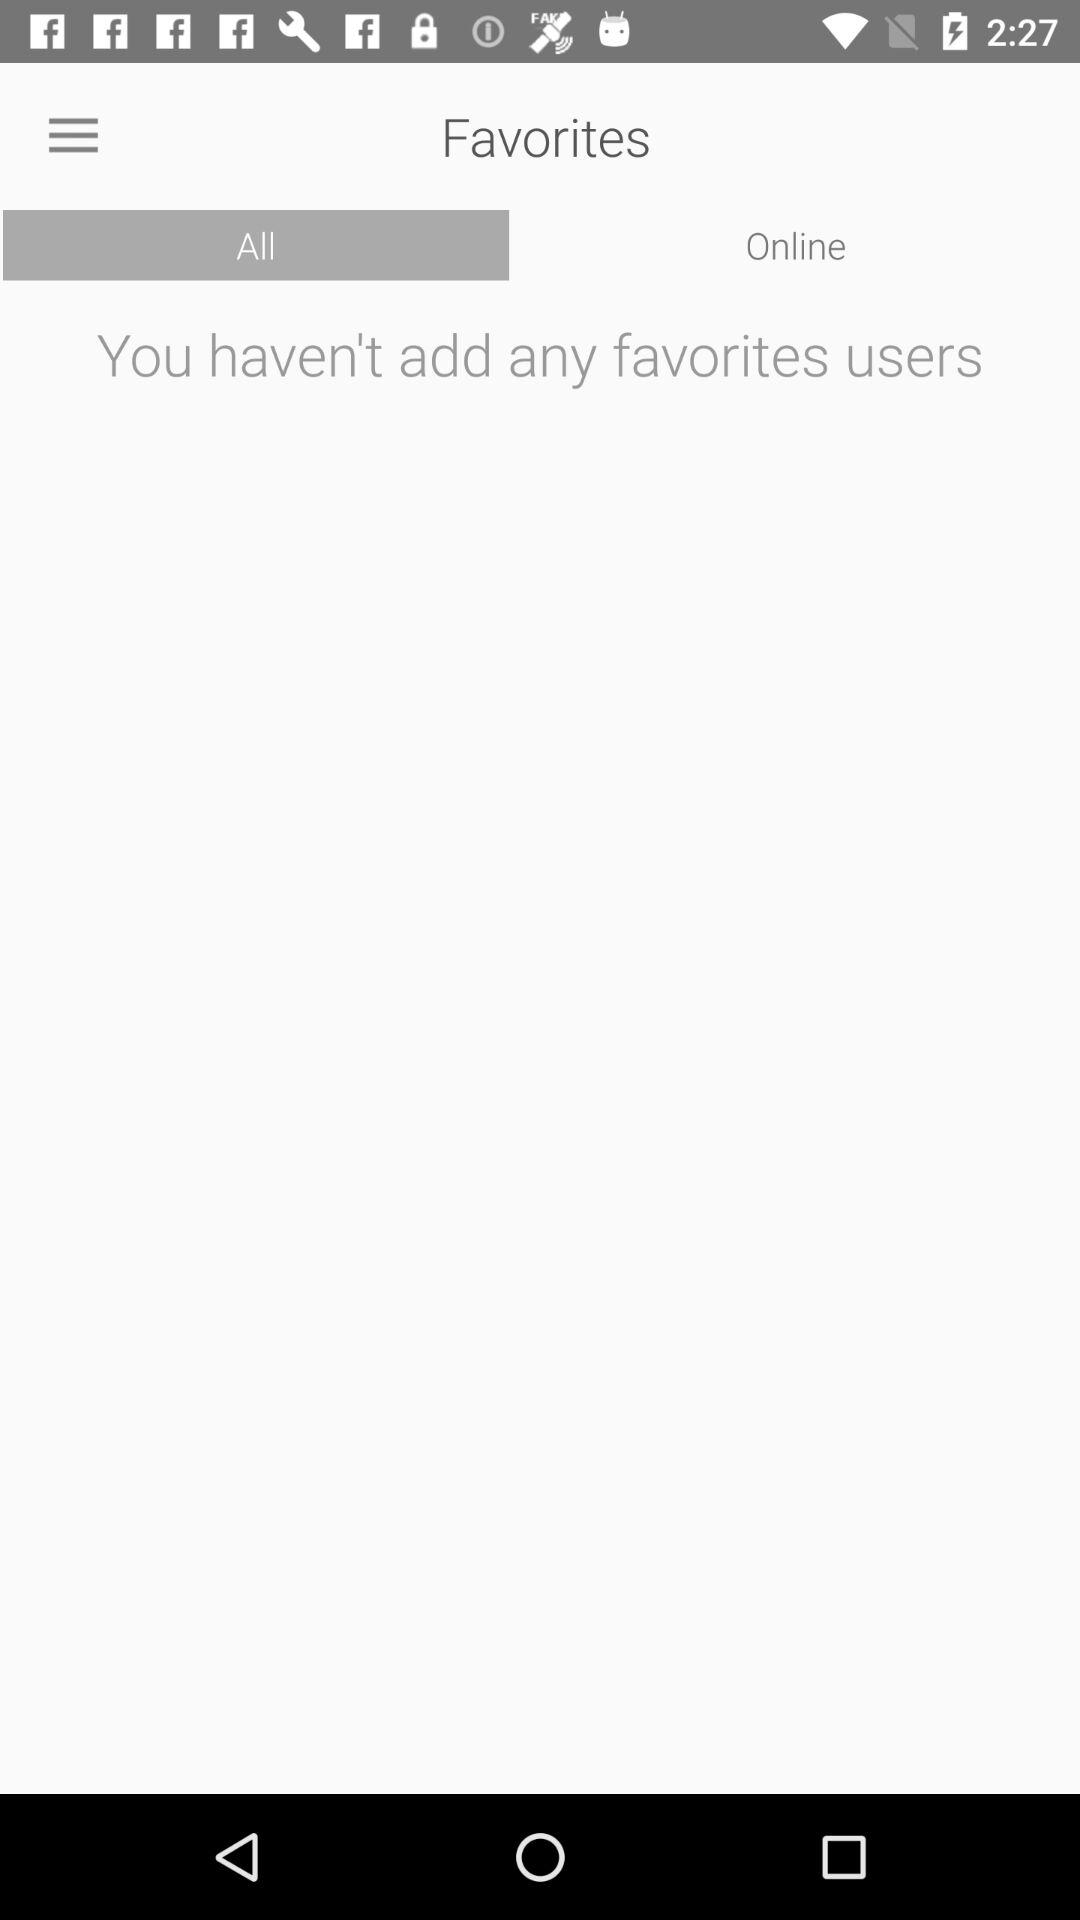Is there any favorite user added?
When the provided information is insufficient, respond with <no answer>. <no answer> 